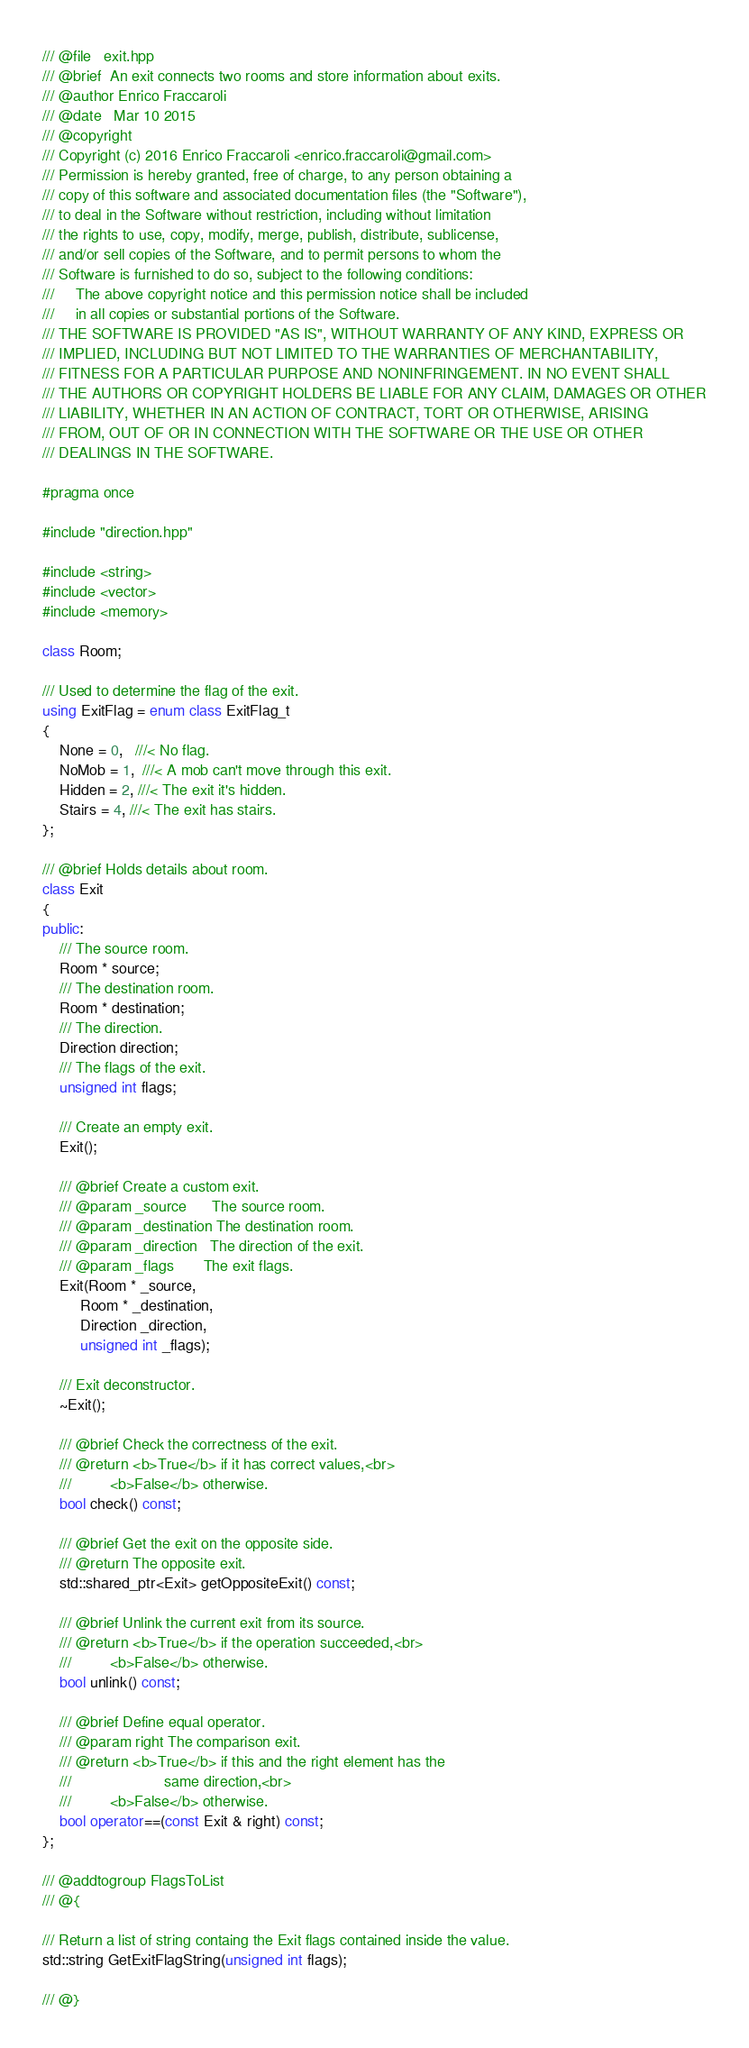Convert code to text. <code><loc_0><loc_0><loc_500><loc_500><_C++_>/// @file   exit.hpp
/// @brief  An exit connects two rooms and store information about exits.
/// @author Enrico Fraccaroli
/// @date   Mar 10 2015
/// @copyright
/// Copyright (c) 2016 Enrico Fraccaroli <enrico.fraccaroli@gmail.com>
/// Permission is hereby granted, free of charge, to any person obtaining a
/// copy of this software and associated documentation files (the "Software"),
/// to deal in the Software without restriction, including without limitation
/// the rights to use, copy, modify, merge, publish, distribute, sublicense,
/// and/or sell copies of the Software, and to permit persons to whom the
/// Software is furnished to do so, subject to the following conditions:
///     The above copyright notice and this permission notice shall be included
///     in all copies or substantial portions of the Software.
/// THE SOFTWARE IS PROVIDED "AS IS", WITHOUT WARRANTY OF ANY KIND, EXPRESS OR
/// IMPLIED, INCLUDING BUT NOT LIMITED TO THE WARRANTIES OF MERCHANTABILITY,
/// FITNESS FOR A PARTICULAR PURPOSE AND NONINFRINGEMENT. IN NO EVENT SHALL
/// THE AUTHORS OR COPYRIGHT HOLDERS BE LIABLE FOR ANY CLAIM, DAMAGES OR OTHER
/// LIABILITY, WHETHER IN AN ACTION OF CONTRACT, TORT OR OTHERWISE, ARISING
/// FROM, OUT OF OR IN CONNECTION WITH THE SOFTWARE OR THE USE OR OTHER
/// DEALINGS IN THE SOFTWARE.

#pragma once

#include "direction.hpp"

#include <string>
#include <vector>
#include <memory>

class Room;

/// Used to determine the flag of the exit.
using ExitFlag = enum class ExitFlag_t
{
    None = 0,   ///< No flag.
    NoMob = 1,  ///< A mob can't move through this exit.
    Hidden = 2, ///< The exit it's hidden.
    Stairs = 4, ///< The exit has stairs.
};

/// @brief Holds details about room.
class Exit
{
public:
    /// The source room.
    Room * source;
    /// The destination room.
    Room * destination;
    /// The direction.
    Direction direction;
    /// The flags of the exit.
    unsigned int flags;

    /// Create an empty exit.
    Exit();

    /// @brief Create a custom exit.
    /// @param _source      The source room.
    /// @param _destination The destination room.
    /// @param _direction   The direction of the exit.
    /// @param _flags       The exit flags.
    Exit(Room * _source,
         Room * _destination,
         Direction _direction,
         unsigned int _flags);

    /// Exit deconstructor.
    ~Exit();

    /// @brief Check the correctness of the exit.
    /// @return <b>True</b> if it has correct values,<br>
    ///         <b>False</b> otherwise.
    bool check() const;

    /// @brief Get the exit on the opposite side.
    /// @return The opposite exit.
    std::shared_ptr<Exit> getOppositeExit() const;

    /// @brief Unlink the current exit from its source.
    /// @return <b>True</b> if the operation succeeded,<br>
    ///         <b>False</b> otherwise.
    bool unlink() const;

    /// @brief Define equal operator.
    /// @param right The comparison exit.
    /// @return <b>True</b> if this and the right element has the
    ///                      same direction,<br>
    ///         <b>False</b> otherwise.
    bool operator==(const Exit & right) const;
};

/// @addtogroup FlagsToList
/// @{

/// Return a list of string containg the Exit flags contained inside the value.
std::string GetExitFlagString(unsigned int flags);

/// @}
</code> 